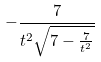<formula> <loc_0><loc_0><loc_500><loc_500>- \frac { 7 } { t ^ { 2 } \sqrt { 7 - \frac { 7 } { t ^ { 2 } } } }</formula> 